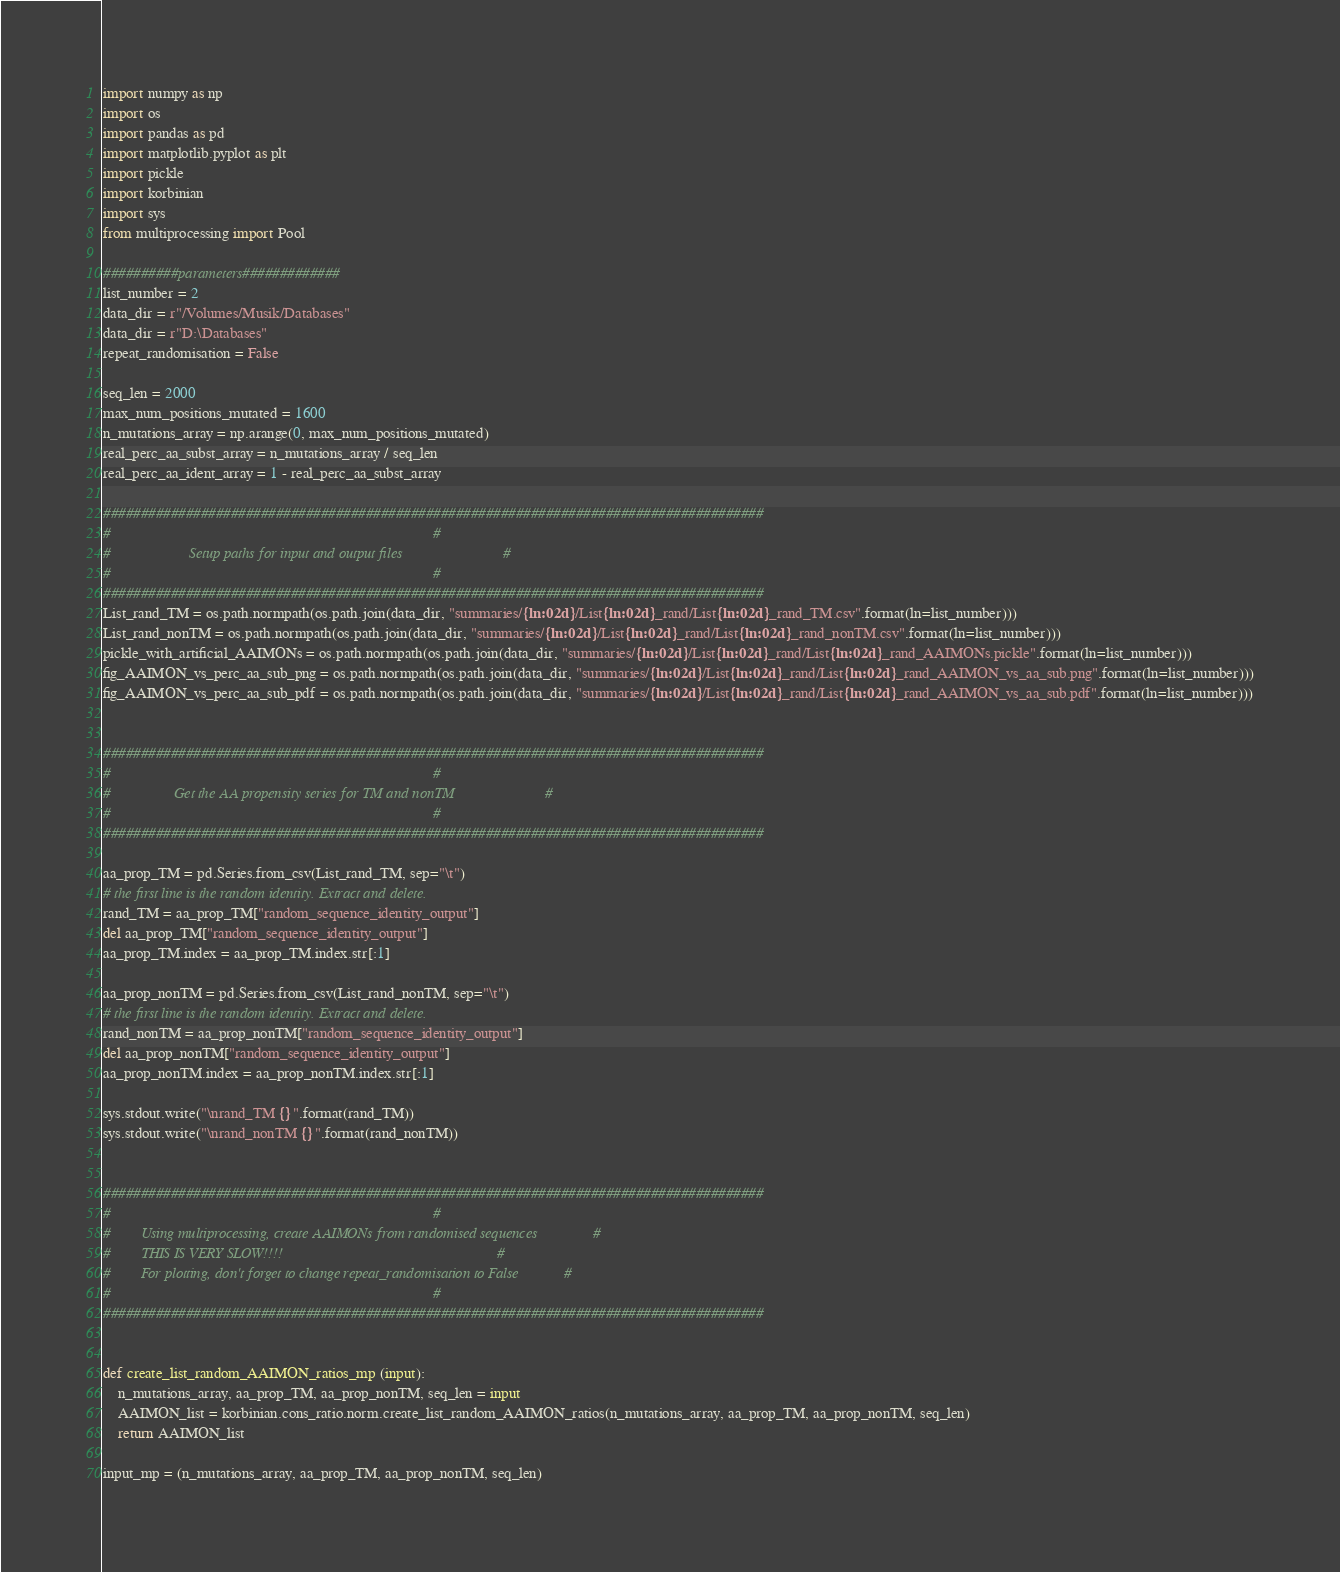<code> <loc_0><loc_0><loc_500><loc_500><_Python_>import numpy as np
import os
import pandas as pd
import matplotlib.pyplot as plt
import pickle
import korbinian
import sys
from multiprocessing import Pool

##########parameters#############
list_number = 2
data_dir = r"/Volumes/Musik/Databases"
data_dir = r"D:\Databases"
repeat_randomisation = False

seq_len = 2000
max_num_positions_mutated = 1600
n_mutations_array = np.arange(0, max_num_positions_mutated)
real_perc_aa_subst_array = n_mutations_array / seq_len
real_perc_aa_ident_array = 1 - real_perc_aa_subst_array

########################################################################################
#                                                                                      #
#                     Setup paths for input and output files                           #
#                                                                                      #
########################################################################################
List_rand_TM = os.path.normpath(os.path.join(data_dir, "summaries/{ln:02d}/List{ln:02d}_rand/List{ln:02d}_rand_TM.csv".format(ln=list_number)))
List_rand_nonTM = os.path.normpath(os.path.join(data_dir, "summaries/{ln:02d}/List{ln:02d}_rand/List{ln:02d}_rand_nonTM.csv".format(ln=list_number)))
pickle_with_artificial_AAIMONs = os.path.normpath(os.path.join(data_dir, "summaries/{ln:02d}/List{ln:02d}_rand/List{ln:02d}_rand_AAIMONs.pickle".format(ln=list_number)))
fig_AAIMON_vs_perc_aa_sub_png = os.path.normpath(os.path.join(data_dir, "summaries/{ln:02d}/List{ln:02d}_rand/List{ln:02d}_rand_AAIMON_vs_aa_sub.png".format(ln=list_number)))
fig_AAIMON_vs_perc_aa_sub_pdf = os.path.normpath(os.path.join(data_dir, "summaries/{ln:02d}/List{ln:02d}_rand/List{ln:02d}_rand_AAIMON_vs_aa_sub.pdf".format(ln=list_number)))


########################################################################################
#                                                                                      #
#                 Get the AA propensity series for TM and nonTM                        #
#                                                                                      #
########################################################################################

aa_prop_TM = pd.Series.from_csv(List_rand_TM, sep="\t")
# the first line is the random identity. Extract and delete.
rand_TM = aa_prop_TM["random_sequence_identity_output"]
del aa_prop_TM["random_sequence_identity_output"]
aa_prop_TM.index = aa_prop_TM.index.str[:1]

aa_prop_nonTM = pd.Series.from_csv(List_rand_nonTM, sep="\t")
# the first line is the random identity. Extract and delete.
rand_nonTM = aa_prop_nonTM["random_sequence_identity_output"]
del aa_prop_nonTM["random_sequence_identity_output"]
aa_prop_nonTM.index = aa_prop_nonTM.index.str[:1]

sys.stdout.write("\nrand_TM {}".format(rand_TM))
sys.stdout.write("\nrand_nonTM {}".format(rand_nonTM))


########################################################################################
#                                                                                      #
#        Using multiprocessing, create AAIMONs from randomised sequences               #
#        THIS IS VERY SLOW!!!!                                                         #
#        For plotting, don't forget to change repeat_randomisation to False            #
#                                                                                      #
########################################################################################


def create_list_random_AAIMON_ratios_mp (input):
    n_mutations_array, aa_prop_TM, aa_prop_nonTM, seq_len = input
    AAIMON_list = korbinian.cons_ratio.norm.create_list_random_AAIMON_ratios(n_mutations_array, aa_prop_TM, aa_prop_nonTM, seq_len)
    return AAIMON_list

input_mp = (n_mutations_array, aa_prop_TM, aa_prop_nonTM, seq_len)</code> 